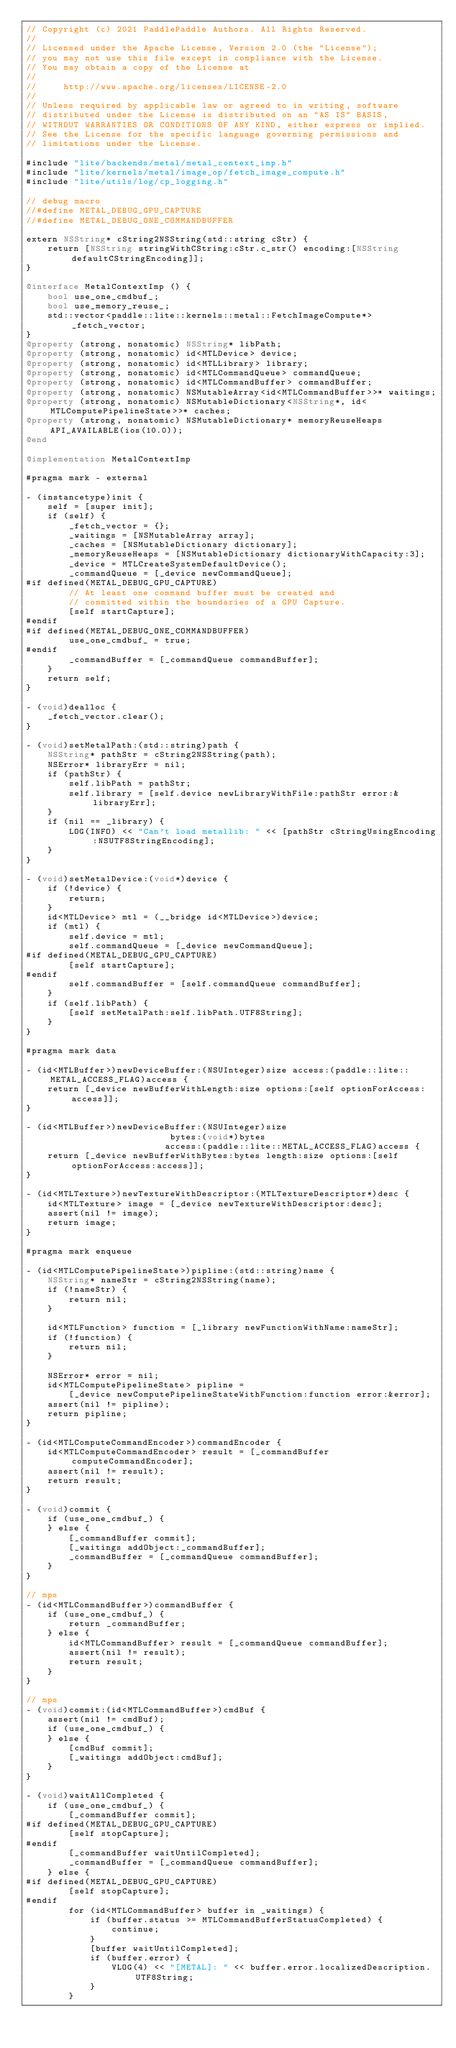Convert code to text. <code><loc_0><loc_0><loc_500><loc_500><_ObjectiveC_>// Copyright (c) 2021 PaddlePaddle Authors. All Rights Reserved.
//
// Licensed under the Apache License, Version 2.0 (the "License");
// you may not use this file except in compliance with the License.
// You may obtain a copy of the License at
//
//     http://www.apache.org/licenses/LICENSE-2.0
//
// Unless required by applicable law or agreed to in writing, software
// distributed under the License is distributed on an "AS IS" BASIS,
// WITHOUT WARRANTIES OR CONDITIONS OF ANY KIND, either express or implied.
// See the License for the specific language governing permissions and
// limitations under the License.

#include "lite/backends/metal/metal_context_imp.h"
#include "lite/kernels/metal/image_op/fetch_image_compute.h"
#include "lite/utils/log/cp_logging.h"

// debug macro
//#define METAL_DEBUG_GPU_CAPTURE
//#define METAL_DEBUG_ONE_COMMANDBUFFER

extern NSString* cString2NSString(std::string cStr) {
    return [NSString stringWithCString:cStr.c_str() encoding:[NSString defaultCStringEncoding]];
}

@interface MetalContextImp () {
    bool use_one_cmdbuf_;
    bool use_memory_reuse_;
    std::vector<paddle::lite::kernels::metal::FetchImageCompute*> _fetch_vector;
}
@property (strong, nonatomic) NSString* libPath;
@property (strong, nonatomic) id<MTLDevice> device;
@property (strong, nonatomic) id<MTLLibrary> library;
@property (strong, nonatomic) id<MTLCommandQueue> commandQueue;
@property (strong, nonatomic) id<MTLCommandBuffer> commandBuffer;
@property (strong, nonatomic) NSMutableArray<id<MTLCommandBuffer>>* waitings;
@property (strong, nonatomic) NSMutableDictionary<NSString*, id<MTLComputePipelineState>>* caches;
@property (strong, nonatomic) NSMutableDictionary* memoryReuseHeaps API_AVAILABLE(ios(10.0));
@end

@implementation MetalContextImp

#pragma mark - external

- (instancetype)init {
    self = [super init];
    if (self) {
        _fetch_vector = {};
        _waitings = [NSMutableArray array];
        _caches = [NSMutableDictionary dictionary];
        _memoryReuseHeaps = [NSMutableDictionary dictionaryWithCapacity:3];
        _device = MTLCreateSystemDefaultDevice();
        _commandQueue = [_device newCommandQueue];
#if defined(METAL_DEBUG_GPU_CAPTURE)
        // At least one command buffer must be created and
        // committed within the boundaries of a GPU Capture.
        [self startCapture];
#endif
#if defined(METAL_DEBUG_ONE_COMMANDBUFFER)
        use_one_cmdbuf_ = true;
#endif
        _commandBuffer = [_commandQueue commandBuffer];
    }
    return self;
}

- (void)dealloc {
    _fetch_vector.clear();
}

- (void)setMetalPath:(std::string)path {
    NSString* pathStr = cString2NSString(path);
    NSError* libraryErr = nil;
    if (pathStr) {
        self.libPath = pathStr;
        self.library = [self.device newLibraryWithFile:pathStr error:&libraryErr];
    }
    if (nil == _library) {
        LOG(INFO) << "Can't load metallib: " << [pathStr cStringUsingEncoding:NSUTF8StringEncoding];
    }
}

- (void)setMetalDevice:(void*)device {
    if (!device) {
        return;
    }
    id<MTLDevice> mtl = (__bridge id<MTLDevice>)device;
    if (mtl) {
        self.device = mtl;
        self.commandQueue = [_device newCommandQueue];
#if defined(METAL_DEBUG_GPU_CAPTURE)
        [self startCapture];
#endif
        self.commandBuffer = [self.commandQueue commandBuffer];
    }
    if (self.libPath) {
        [self setMetalPath:self.libPath.UTF8String];
    }
}

#pragma mark data

- (id<MTLBuffer>)newDeviceBuffer:(NSUInteger)size access:(paddle::lite::METAL_ACCESS_FLAG)access {
    return [_device newBufferWithLength:size options:[self optionForAccess:access]];
}

- (id<MTLBuffer>)newDeviceBuffer:(NSUInteger)size
                           bytes:(void*)bytes
                          access:(paddle::lite::METAL_ACCESS_FLAG)access {
    return [_device newBufferWithBytes:bytes length:size options:[self optionForAccess:access]];
}

- (id<MTLTexture>)newTextureWithDescriptor:(MTLTextureDescriptor*)desc {
    id<MTLTexture> image = [_device newTextureWithDescriptor:desc];
    assert(nil != image);
    return image;
}

#pragma mark enqueue

- (id<MTLComputePipelineState>)pipline:(std::string)name {
    NSString* nameStr = cString2NSString(name);
    if (!nameStr) {
        return nil;
    }

    id<MTLFunction> function = [_library newFunctionWithName:nameStr];
    if (!function) {
        return nil;
    }

    NSError* error = nil;
    id<MTLComputePipelineState> pipline =
        [_device newComputePipelineStateWithFunction:function error:&error];
    assert(nil != pipline);
    return pipline;
}

- (id<MTLComputeCommandEncoder>)commandEncoder {
    id<MTLComputeCommandEncoder> result = [_commandBuffer computeCommandEncoder];
    assert(nil != result);
    return result;
}

- (void)commit {
    if (use_one_cmdbuf_) {
    } else {
        [_commandBuffer commit];
        [_waitings addObject:_commandBuffer];
        _commandBuffer = [_commandQueue commandBuffer];
    }
}

// mps
- (id<MTLCommandBuffer>)commandBuffer {
    if (use_one_cmdbuf_) {
        return _commandBuffer;
    } else {
        id<MTLCommandBuffer> result = [_commandQueue commandBuffer];
        assert(nil != result);
        return result;
    }
}

// mps
- (void)commit:(id<MTLCommandBuffer>)cmdBuf {
    assert(nil != cmdBuf);
    if (use_one_cmdbuf_) {
    } else {
        [cmdBuf commit];
        [_waitings addObject:cmdBuf];
    }
}

- (void)waitAllCompleted {
    if (use_one_cmdbuf_) {
        [_commandBuffer commit];
#if defined(METAL_DEBUG_GPU_CAPTURE)
        [self stopCapture];
#endif
        [_commandBuffer waitUntilCompleted];
        _commandBuffer = [_commandQueue commandBuffer];
    } else {
#if defined(METAL_DEBUG_GPU_CAPTURE)
        [self stopCapture];
#endif
        for (id<MTLCommandBuffer> buffer in _waitings) {
            if (buffer.status >= MTLCommandBufferStatusCompleted) {
                continue;
            }
            [buffer waitUntilCompleted];
            if (buffer.error) {
                VLOG(4) << "[METAL]: " << buffer.error.localizedDescription.UTF8String;
            }
        }</code> 